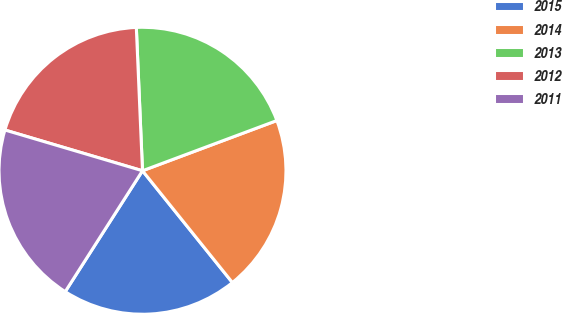Convert chart to OTSL. <chart><loc_0><loc_0><loc_500><loc_500><pie_chart><fcel>2015<fcel>2014<fcel>2013<fcel>2012<fcel>2011<nl><fcel>19.83%<fcel>19.91%<fcel>19.99%<fcel>19.73%<fcel>20.53%<nl></chart> 